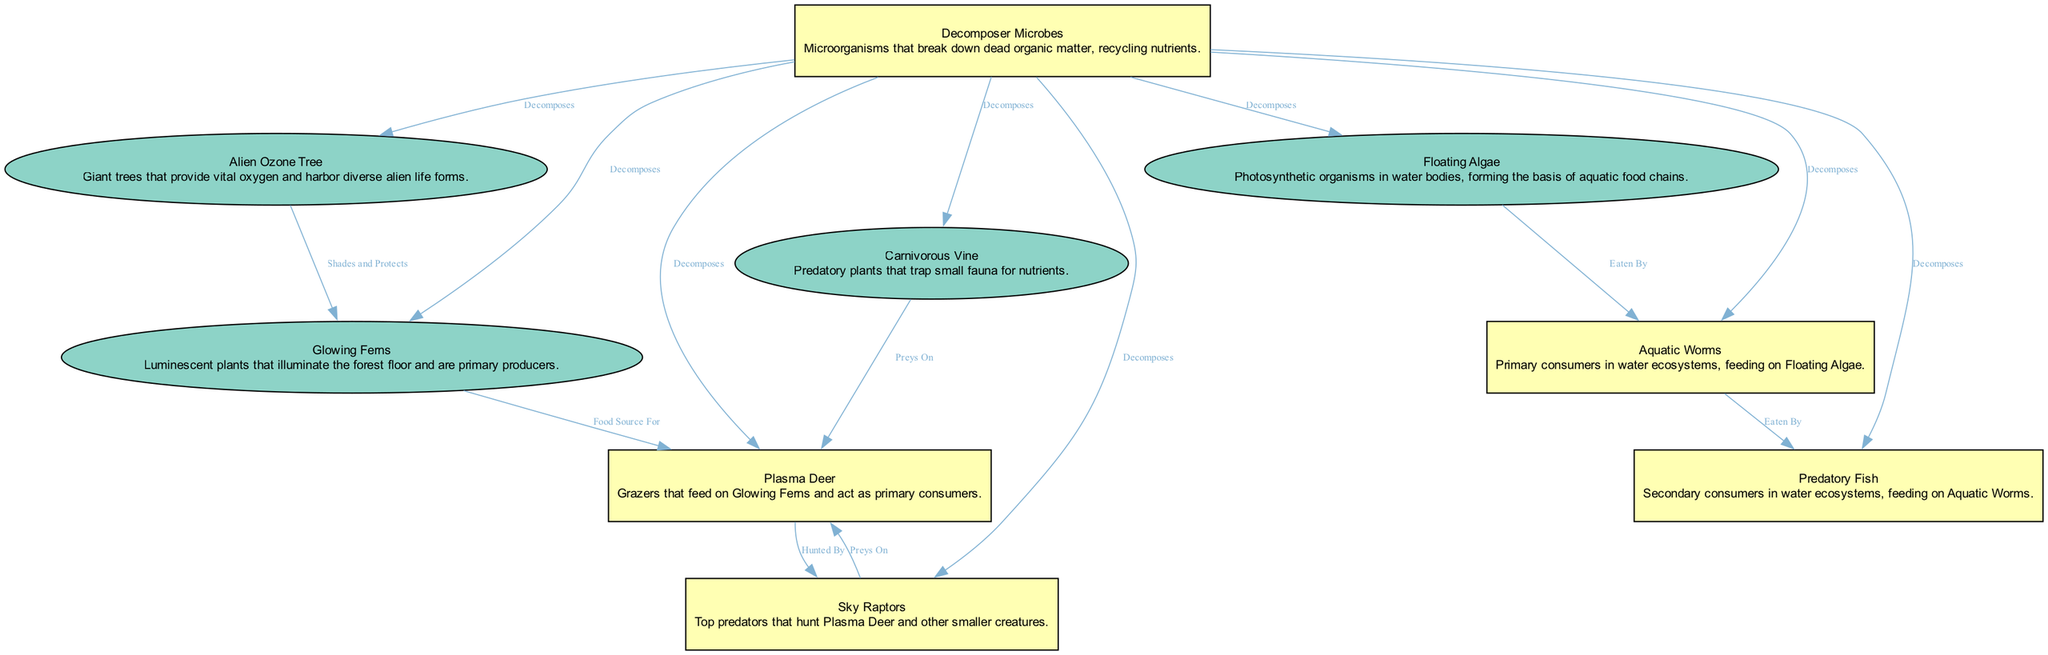What is the role of the Alien Ozone Tree in the ecosystem? The Alien Ozone Tree provides vital oxygen and offers protection by shading other plants like the Glowing Ferns. This is depicted as it connects to the Glowing Ferns with the label "Shades and Protects."
Answer: Vital oxygen and protects How many types of fauna are present in the ecosystem? The diagram lists three types of fauna: Plasma Deer, Sky Raptors, and Aquatic Worms. By counting the nodes labeled as fauna, we identify three distinct types.
Answer: Three What does the Carnivorous Vine primarily do? The Carnivorous Vine is responsible for preying on small fauna, particularly the Plasma Deer, as indicated by the edge stating "Preys On."
Answer: Preys on small fauna Which organisms are involved in the aquatic food chain? The aquatic food chain incorporates Floating Algae, Aquatic Worms, and Predatory Fish. The relationships show how Floating Algae are eaten by Aquatic Worms, and Aquatic Worms are eaten by Predatory Fish.
Answer: Floating Algae, Aquatic Worms, Predatory Fish What type of consumers are Predatory Fish in the ecosystem? Predatory Fish are classified as secondary consumers as they rely on Aquatic Worms, which are primary consumers. Their relationship is shown in the label "Eaten By," indicating they consume the former.
Answer: Secondary consumers How does the Decomposer Microbes influence the ecosystem? Decomposer Microbes break down dead organic matter, recycling nutrients, as noted in the edge labeled "Decomposes." This lack of specificity towards a target node shows its importance across the ecosystem.
Answer: Recycles nutrients What is the relationship between Plasma Deer and Sky Raptors? The Sky Raptors hunt Plasma Deer, which is indicated by the "Hunted By" label connecting these two species. This establishes a predator-prey relationship within the food chain.
Answer: Sky Raptors hunt Plasma Deer Which organism acts as the primary producer in the ecosystem? The Glowing Ferns are identified as primary producers because they provide food for the Plasma Deer, as labeled in the edge "Food Source For."
Answer: Glowing Ferns What is the main source of nutrients for the Carnivorous Vine? The Carnivorous Vine obtains nutrients by trapping and preying on small fauna, particularly targeting organisms like the Plasma Deer, as described by the edge "Preys On."
Answer: Small fauna 